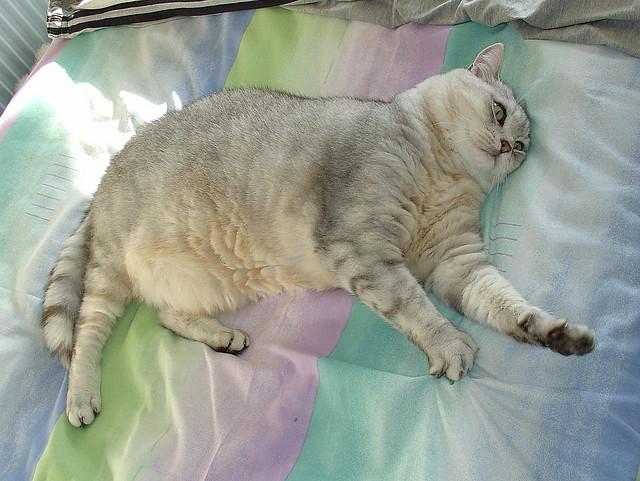Was this taken in the daytime?
Be succinct. Yes. Is the bed cover a solid color?
Concise answer only. No. Why is this cat laying on the bed?
Answer briefly. Yes. 